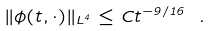<formula> <loc_0><loc_0><loc_500><loc_500>\| \phi ( t , \cdot ) \| _ { L ^ { 4 } } \leq C t ^ { - 9 / 1 6 } \ .</formula> 